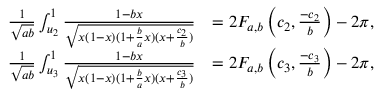Convert formula to latex. <formula><loc_0><loc_0><loc_500><loc_500>\begin{array} { r l } { \frac { 1 } { \sqrt { a b } } \int _ { u _ { 2 } } ^ { 1 } \frac { 1 - b x } { \sqrt { x ( 1 - x ) ( 1 + \frac { b } { a } x ) ( x + \frac { c _ { 2 } } { b } ) } } } & { = 2 F _ { a , b } \left ( c _ { 2 } , \frac { - c _ { 2 } } { b } \right ) - 2 \pi , } \\ { \frac { 1 } { \sqrt { a b } } \int _ { u _ { 3 } } ^ { 1 } \frac { 1 - b x } { \sqrt { x ( 1 - x ) ( 1 + \frac { b } { a } x ) ( x + \frac { c _ { 3 } } { b } ) } } } & { = 2 F _ { a , b } \left ( c _ { 3 } , \frac { - c _ { 3 } } { b } \right ) - 2 \pi , } \end{array}</formula> 